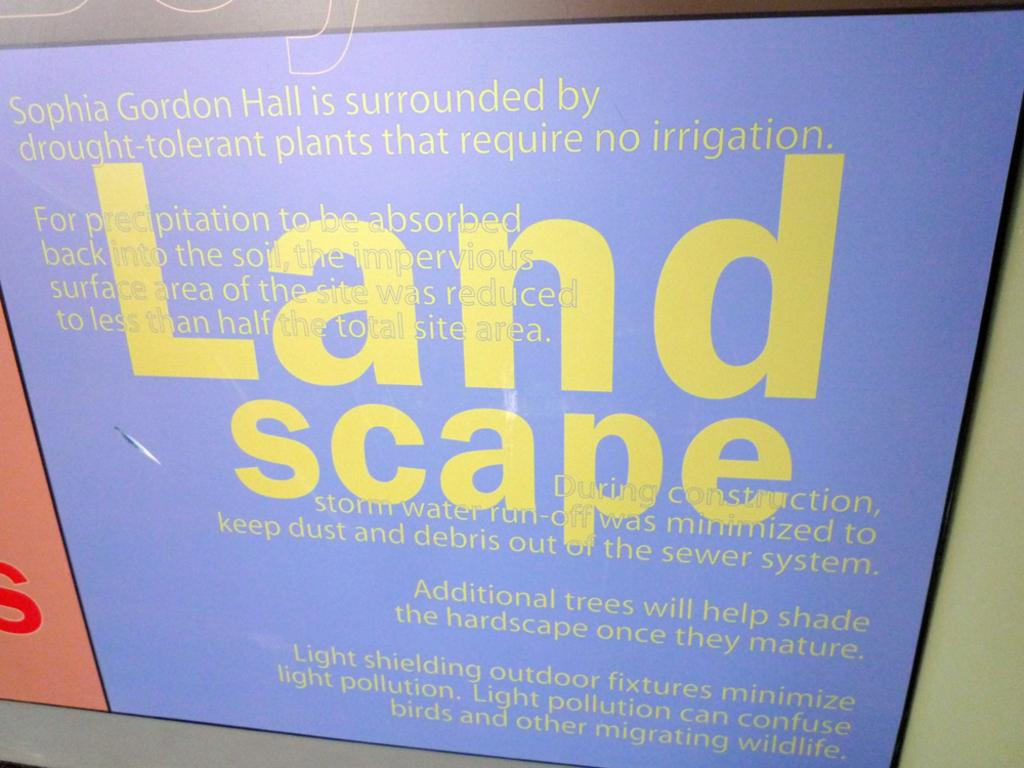Provide a one-sentence caption for the provided image. A sign informs visitors of the contents of an area's landscape. 